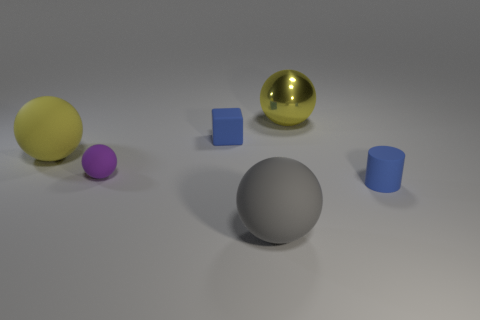Subtract all yellow shiny spheres. How many spheres are left? 3 Subtract all purple balls. How many balls are left? 3 Subtract all spheres. How many objects are left? 2 Subtract 1 blocks. How many blocks are left? 0 Add 1 big red cylinders. How many big red cylinders exist? 1 Add 4 large blue rubber objects. How many objects exist? 10 Subtract 0 cyan spheres. How many objects are left? 6 Subtract all blue balls. Subtract all green cylinders. How many balls are left? 4 Subtract all purple balls. How many green cubes are left? 0 Subtract all large yellow spheres. Subtract all big yellow matte spheres. How many objects are left? 3 